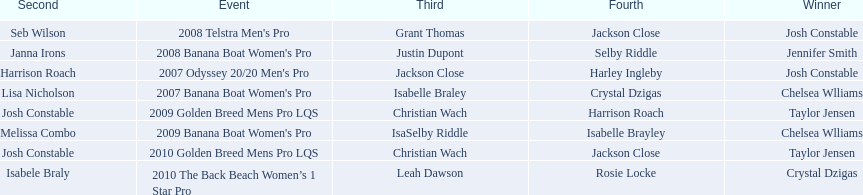What is the total number of times chelsea williams was the winner between 2007 and 2010? 2. Can you give me this table as a dict? {'header': ['Second', 'Event', 'Third', 'Fourth', 'Winner'], 'rows': [['Seb Wilson', "2008 Telstra Men's Pro", 'Grant Thomas', 'Jackson Close', 'Josh Constable'], ['Janna Irons', "2008 Banana Boat Women's Pro", 'Justin Dupont', 'Selby Riddle', 'Jennifer Smith'], ['Harrison Roach', "2007 Odyssey 20/20 Men's Pro", 'Jackson Close', 'Harley Ingleby', 'Josh Constable'], ['Lisa Nicholson', "2007 Banana Boat Women's Pro", 'Isabelle Braley', 'Crystal Dzigas', 'Chelsea Wlliams'], ['Josh Constable', '2009 Golden Breed Mens Pro LQS', 'Christian Wach', 'Harrison Roach', 'Taylor Jensen'], ['Melissa Combo', "2009 Banana Boat Women's Pro", 'IsaSelby Riddle', 'Isabelle Brayley', 'Chelsea Wlliams'], ['Josh Constable', '2010 Golden Breed Mens Pro LQS', 'Christian Wach', 'Jackson Close', 'Taylor Jensen'], ['Isabele Braly', '2010 The Back Beach Women’s 1 Star Pro', 'Leah Dawson', 'Rosie Locke', 'Crystal Dzigas']]} 